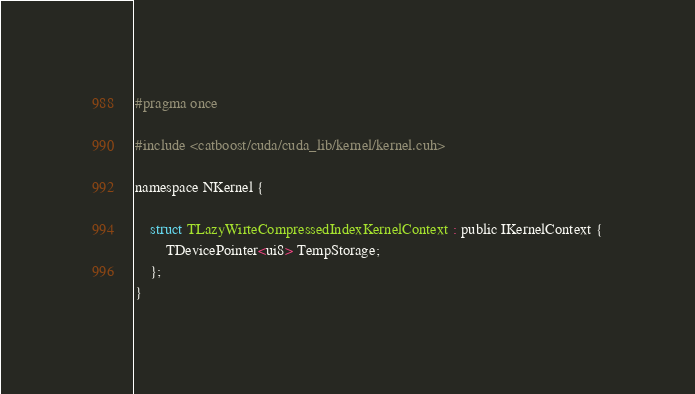Convert code to text. <code><loc_0><loc_0><loc_500><loc_500><_Cuda_>#pragma once

#include <catboost/cuda/cuda_lib/kernel/kernel.cuh>

namespace NKernel {

    struct TLazyWirteCompressedIndexKernelContext : public IKernelContext {
        TDevicePointer<ui8> TempStorage;
    };
}
</code> 